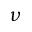Convert formula to latex. <formula><loc_0><loc_0><loc_500><loc_500>\nu</formula> 